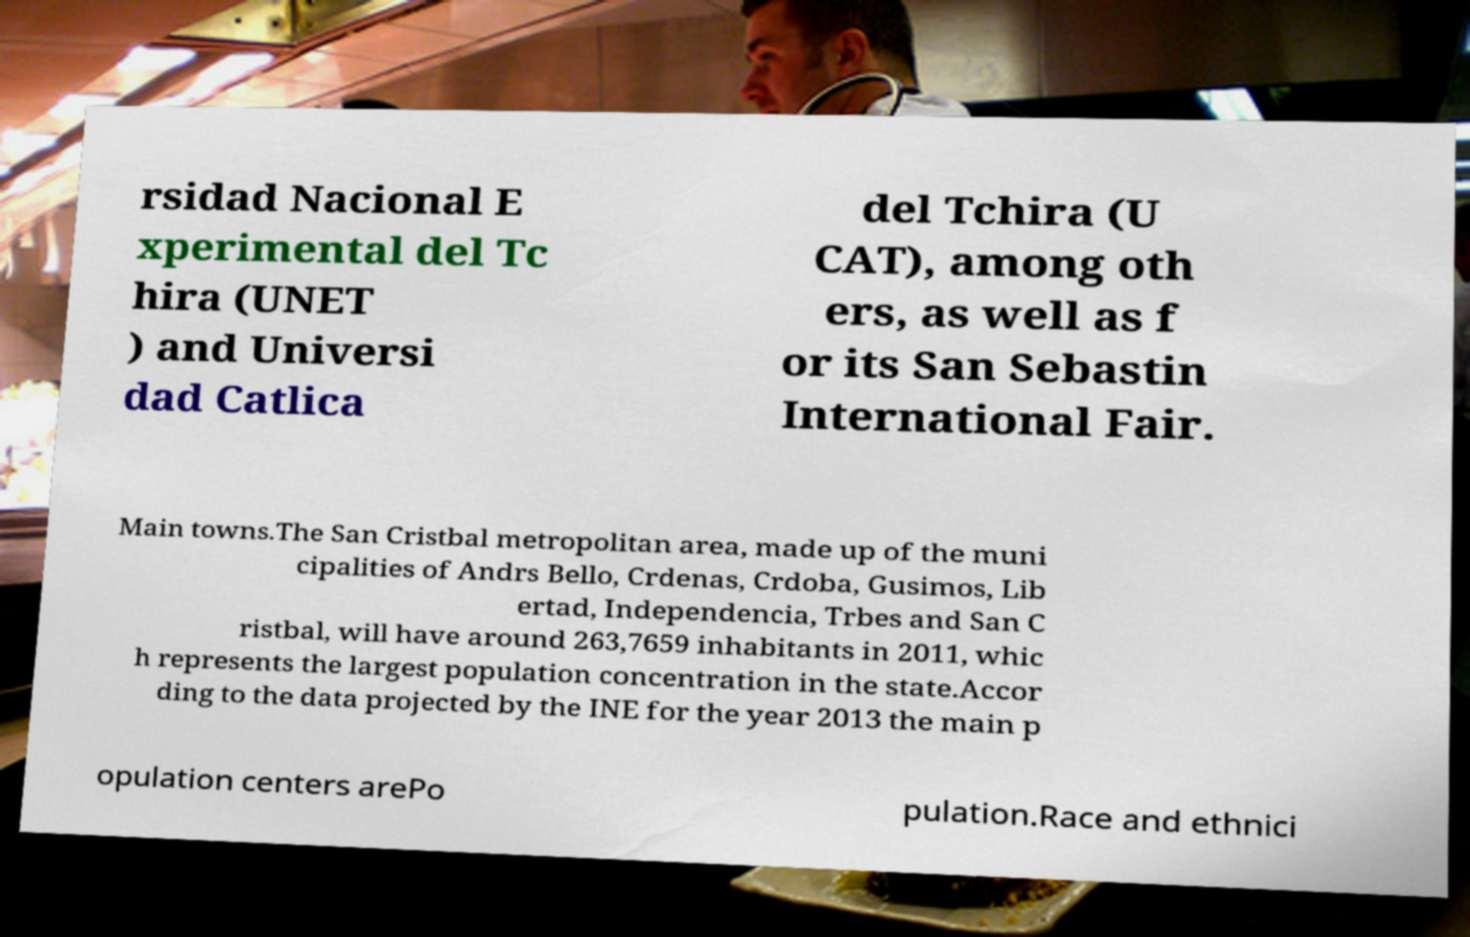For documentation purposes, I need the text within this image transcribed. Could you provide that? rsidad Nacional E xperimental del Tc hira (UNET ) and Universi dad Catlica del Tchira (U CAT), among oth ers, as well as f or its San Sebastin International Fair. Main towns.The San Cristbal metropolitan area, made up of the muni cipalities of Andrs Bello, Crdenas, Crdoba, Gusimos, Lib ertad, Independencia, Trbes and San C ristbal, will have around 263,7659 inhabitants in 2011, whic h represents the largest population concentration in the state.Accor ding to the data projected by the INE for the year 2013 the main p opulation centers arePo pulation.Race and ethnici 